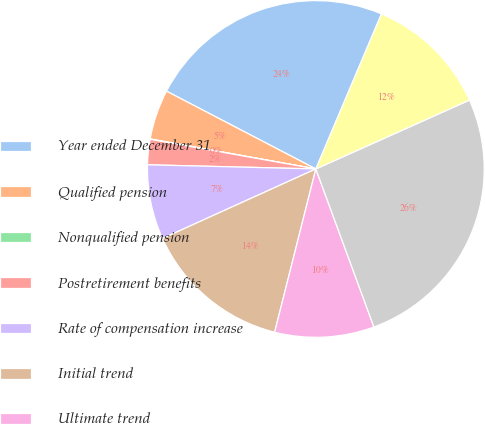Convert chart to OTSL. <chart><loc_0><loc_0><loc_500><loc_500><pie_chart><fcel>Year ended December 31<fcel>Qualified pension<fcel>Nonqualified pension<fcel>Postretirement benefits<fcel>Rate of compensation increase<fcel>Initial trend<fcel>Ultimate trend<fcel>Year ultimate reached<fcel>Expected long-term return on<nl><fcel>23.73%<fcel>4.79%<fcel>0.04%<fcel>2.42%<fcel>7.17%<fcel>14.29%<fcel>9.54%<fcel>26.1%<fcel>11.92%<nl></chart> 